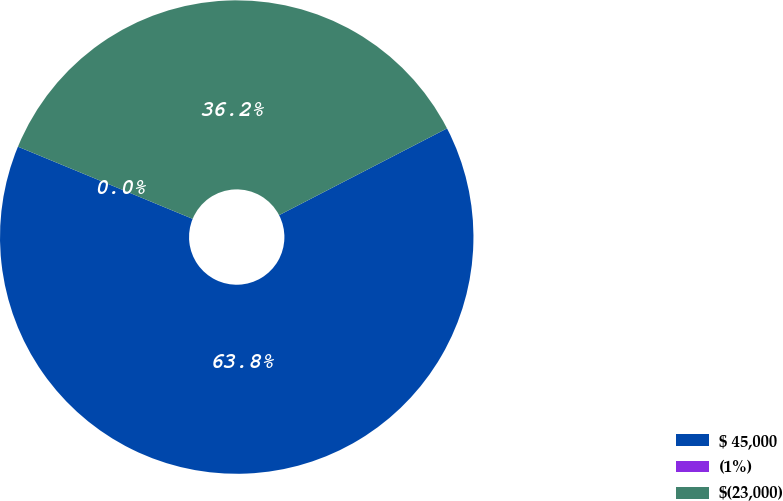Convert chart to OTSL. <chart><loc_0><loc_0><loc_500><loc_500><pie_chart><fcel>$ 45,000<fcel>(1%)<fcel>$(23,000)<nl><fcel>63.82%<fcel>0.0%<fcel>36.17%<nl></chart> 